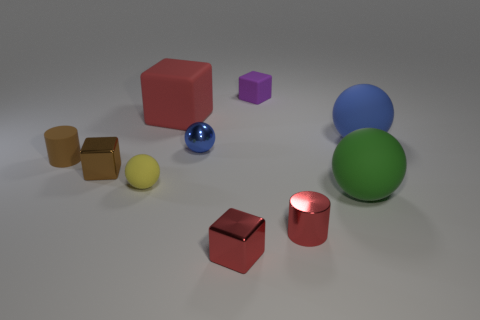Are there any purple matte things left of the big green ball?
Offer a terse response. Yes. There is a large object that is left of the small matte cube; what number of objects are in front of it?
Provide a short and direct response. 8. What is the size of the other block that is made of the same material as the purple cube?
Provide a short and direct response. Large. How big is the blue rubber thing?
Provide a short and direct response. Large. Does the brown cube have the same material as the tiny red cylinder?
Offer a very short reply. Yes. How many balls are large rubber things or tiny matte objects?
Keep it short and to the point. 3. What color is the small object that is behind the red thing behind the tiny blue sphere?
Your response must be concise. Purple. There is a block that is the same color as the rubber cylinder; what size is it?
Offer a very short reply. Small. What number of things are in front of the small thing right of the rubber cube on the right side of the tiny blue thing?
Your response must be concise. 1. Does the red shiny object left of the red cylinder have the same shape as the small thing that is behind the big blue ball?
Offer a terse response. Yes. 